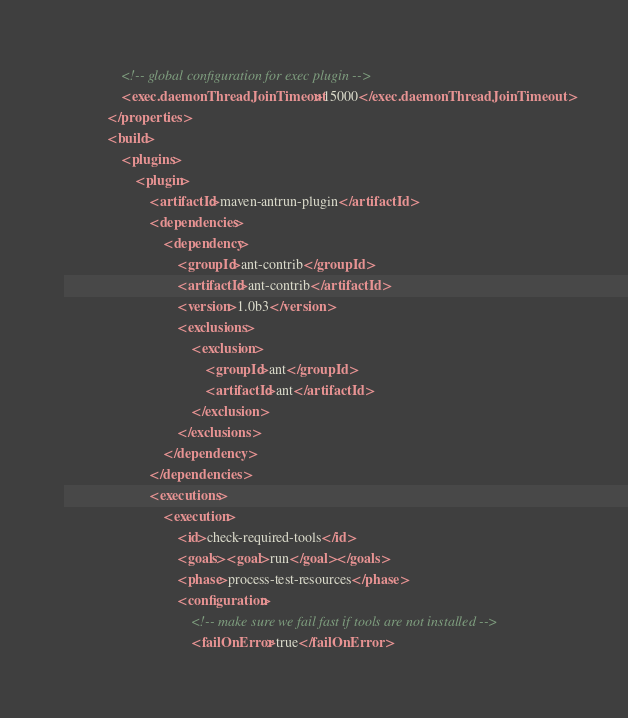Convert code to text. <code><loc_0><loc_0><loc_500><loc_500><_XML_>
                <!-- global configuration for exec plugin -->
                <exec.daemonThreadJoinTimeout>15000</exec.daemonThreadJoinTimeout>
            </properties>
            <build>
                <plugins>
                    <plugin>
                        <artifactId>maven-antrun-plugin</artifactId>
                        <dependencies>
                            <dependency>
                                <groupId>ant-contrib</groupId>
                                <artifactId>ant-contrib</artifactId>
                                <version>1.0b3</version>
                                <exclusions>
                                    <exclusion>
                                        <groupId>ant</groupId>
                                        <artifactId>ant</artifactId>
                                    </exclusion>
                                </exclusions>
                            </dependency>
                        </dependencies>
                        <executions>
                            <execution>
                                <id>check-required-tools</id>
                                <goals><goal>run</goal></goals>
                                <phase>process-test-resources</phase>
                                <configuration>
                                    <!-- make sure we fail fast if tools are not installed -->
                                    <failOnError>true</failOnError></code> 